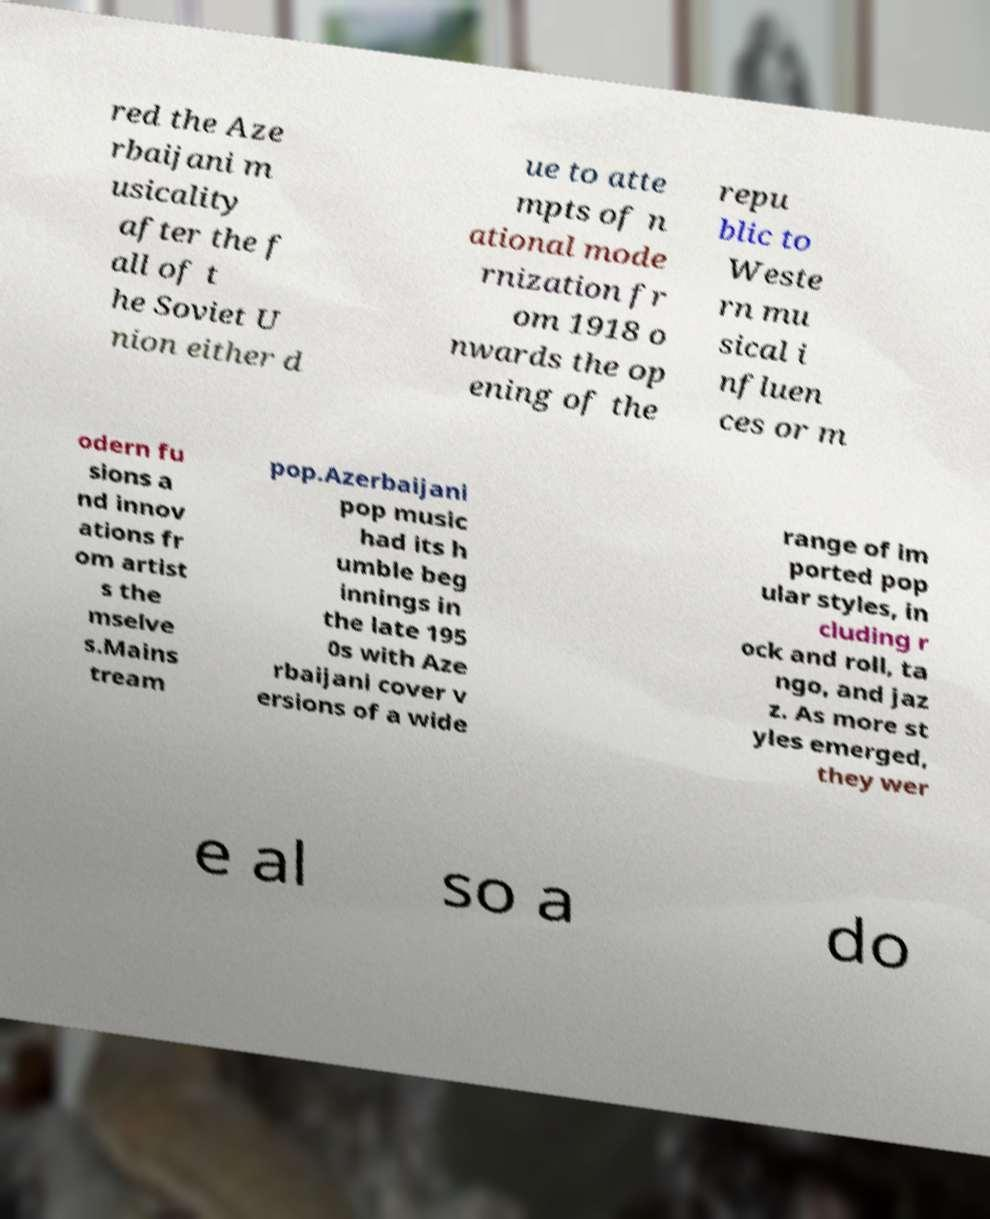Could you assist in decoding the text presented in this image and type it out clearly? red the Aze rbaijani m usicality after the f all of t he Soviet U nion either d ue to atte mpts of n ational mode rnization fr om 1918 o nwards the op ening of the repu blic to Weste rn mu sical i nfluen ces or m odern fu sions a nd innov ations fr om artist s the mselve s.Mains tream pop.Azerbaijani pop music had its h umble beg innings in the late 195 0s with Aze rbaijani cover v ersions of a wide range of im ported pop ular styles, in cluding r ock and roll, ta ngo, and jaz z. As more st yles emerged, they wer e al so a do 